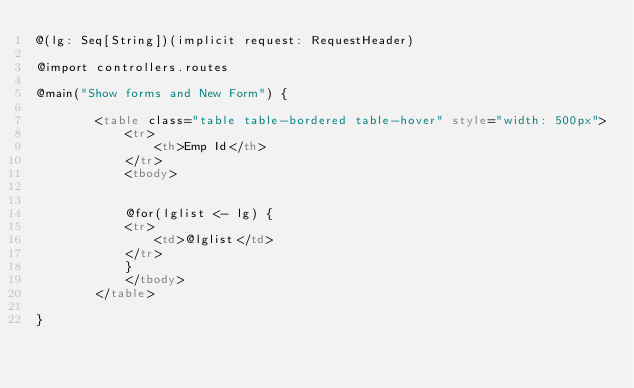<code> <loc_0><loc_0><loc_500><loc_500><_HTML_>@(lg: Seq[String])(implicit request: RequestHeader)

@import controllers.routes

@main("Show forms and New Form") {

        <table class="table table-bordered table-hover" style="width: 500px">
            <tr>
                <th>Emp Id</th>
            </tr>
            <tbody>


            @for(lglist <- lg) {
            <tr>
                <td>@lglist</td>
            </tr>
            }
            </tbody>
        </table>

}

</code> 